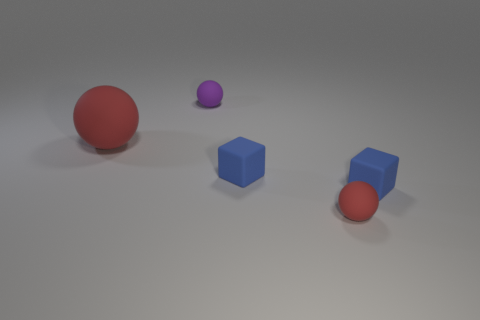What can you tell me about the lighting and shadows in the image? The lighting in the image seems to come from the upper left, casting shadows toward the bottom right. The red and purple balls have soft shadows indicating a diffuse light source, while the blue cube and cylinders have slightly more defined shadows, suggesting that the light is softer but still has a particular direction. 